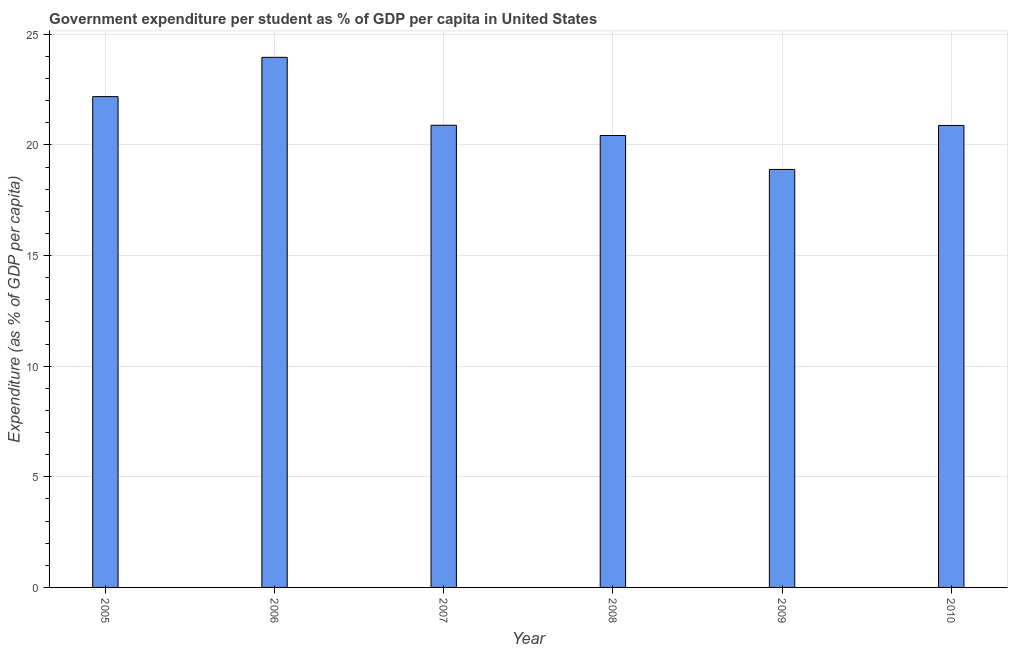Does the graph contain any zero values?
Your answer should be compact. No. What is the title of the graph?
Make the answer very short. Government expenditure per student as % of GDP per capita in United States. What is the label or title of the X-axis?
Provide a succinct answer. Year. What is the label or title of the Y-axis?
Ensure brevity in your answer.  Expenditure (as % of GDP per capita). What is the government expenditure per student in 2006?
Give a very brief answer. 23.96. Across all years, what is the maximum government expenditure per student?
Provide a succinct answer. 23.96. Across all years, what is the minimum government expenditure per student?
Your response must be concise. 18.89. In which year was the government expenditure per student minimum?
Provide a short and direct response. 2009. What is the sum of the government expenditure per student?
Your response must be concise. 127.23. What is the difference between the government expenditure per student in 2008 and 2010?
Offer a terse response. -0.46. What is the average government expenditure per student per year?
Your answer should be compact. 21.2. What is the median government expenditure per student?
Your answer should be very brief. 20.88. In how many years, is the government expenditure per student greater than 23 %?
Your answer should be very brief. 1. What is the ratio of the government expenditure per student in 2005 to that in 2008?
Provide a short and direct response. 1.09. Is the difference between the government expenditure per student in 2007 and 2008 greater than the difference between any two years?
Offer a terse response. No. What is the difference between the highest and the second highest government expenditure per student?
Provide a short and direct response. 1.78. What is the difference between the highest and the lowest government expenditure per student?
Your response must be concise. 5.07. In how many years, is the government expenditure per student greater than the average government expenditure per student taken over all years?
Make the answer very short. 2. How many bars are there?
Keep it short and to the point. 6. How many years are there in the graph?
Offer a very short reply. 6. What is the difference between two consecutive major ticks on the Y-axis?
Offer a very short reply. 5. Are the values on the major ticks of Y-axis written in scientific E-notation?
Provide a succinct answer. No. What is the Expenditure (as % of GDP per capita) of 2005?
Keep it short and to the point. 22.18. What is the Expenditure (as % of GDP per capita) in 2006?
Your response must be concise. 23.96. What is the Expenditure (as % of GDP per capita) of 2007?
Keep it short and to the point. 20.89. What is the Expenditure (as % of GDP per capita) of 2008?
Give a very brief answer. 20.43. What is the Expenditure (as % of GDP per capita) in 2009?
Make the answer very short. 18.89. What is the Expenditure (as % of GDP per capita) in 2010?
Offer a very short reply. 20.88. What is the difference between the Expenditure (as % of GDP per capita) in 2005 and 2006?
Provide a short and direct response. -1.78. What is the difference between the Expenditure (as % of GDP per capita) in 2005 and 2007?
Offer a terse response. 1.29. What is the difference between the Expenditure (as % of GDP per capita) in 2005 and 2008?
Your response must be concise. 1.76. What is the difference between the Expenditure (as % of GDP per capita) in 2005 and 2009?
Keep it short and to the point. 3.29. What is the difference between the Expenditure (as % of GDP per capita) in 2005 and 2010?
Provide a short and direct response. 1.3. What is the difference between the Expenditure (as % of GDP per capita) in 2006 and 2007?
Give a very brief answer. 3.07. What is the difference between the Expenditure (as % of GDP per capita) in 2006 and 2008?
Your answer should be compact. 3.53. What is the difference between the Expenditure (as % of GDP per capita) in 2006 and 2009?
Ensure brevity in your answer.  5.07. What is the difference between the Expenditure (as % of GDP per capita) in 2006 and 2010?
Provide a short and direct response. 3.08. What is the difference between the Expenditure (as % of GDP per capita) in 2007 and 2008?
Offer a very short reply. 0.46. What is the difference between the Expenditure (as % of GDP per capita) in 2007 and 2009?
Offer a terse response. 2. What is the difference between the Expenditure (as % of GDP per capita) in 2007 and 2010?
Make the answer very short. 0.01. What is the difference between the Expenditure (as % of GDP per capita) in 2008 and 2009?
Provide a succinct answer. 1.53. What is the difference between the Expenditure (as % of GDP per capita) in 2008 and 2010?
Your answer should be compact. -0.45. What is the difference between the Expenditure (as % of GDP per capita) in 2009 and 2010?
Offer a terse response. -1.99. What is the ratio of the Expenditure (as % of GDP per capita) in 2005 to that in 2006?
Provide a succinct answer. 0.93. What is the ratio of the Expenditure (as % of GDP per capita) in 2005 to that in 2007?
Offer a very short reply. 1.06. What is the ratio of the Expenditure (as % of GDP per capita) in 2005 to that in 2008?
Ensure brevity in your answer.  1.09. What is the ratio of the Expenditure (as % of GDP per capita) in 2005 to that in 2009?
Ensure brevity in your answer.  1.17. What is the ratio of the Expenditure (as % of GDP per capita) in 2005 to that in 2010?
Provide a short and direct response. 1.06. What is the ratio of the Expenditure (as % of GDP per capita) in 2006 to that in 2007?
Provide a short and direct response. 1.15. What is the ratio of the Expenditure (as % of GDP per capita) in 2006 to that in 2008?
Keep it short and to the point. 1.17. What is the ratio of the Expenditure (as % of GDP per capita) in 2006 to that in 2009?
Make the answer very short. 1.27. What is the ratio of the Expenditure (as % of GDP per capita) in 2006 to that in 2010?
Offer a very short reply. 1.15. What is the ratio of the Expenditure (as % of GDP per capita) in 2007 to that in 2008?
Your answer should be very brief. 1.02. What is the ratio of the Expenditure (as % of GDP per capita) in 2007 to that in 2009?
Give a very brief answer. 1.11. What is the ratio of the Expenditure (as % of GDP per capita) in 2007 to that in 2010?
Your response must be concise. 1. What is the ratio of the Expenditure (as % of GDP per capita) in 2008 to that in 2009?
Your answer should be very brief. 1.08. What is the ratio of the Expenditure (as % of GDP per capita) in 2008 to that in 2010?
Provide a short and direct response. 0.98. What is the ratio of the Expenditure (as % of GDP per capita) in 2009 to that in 2010?
Ensure brevity in your answer.  0.91. 